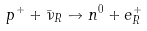Convert formula to latex. <formula><loc_0><loc_0><loc_500><loc_500>p ^ { + } + \bar { \nu } _ { R } \to n ^ { 0 } + e ^ { + } _ { R }</formula> 